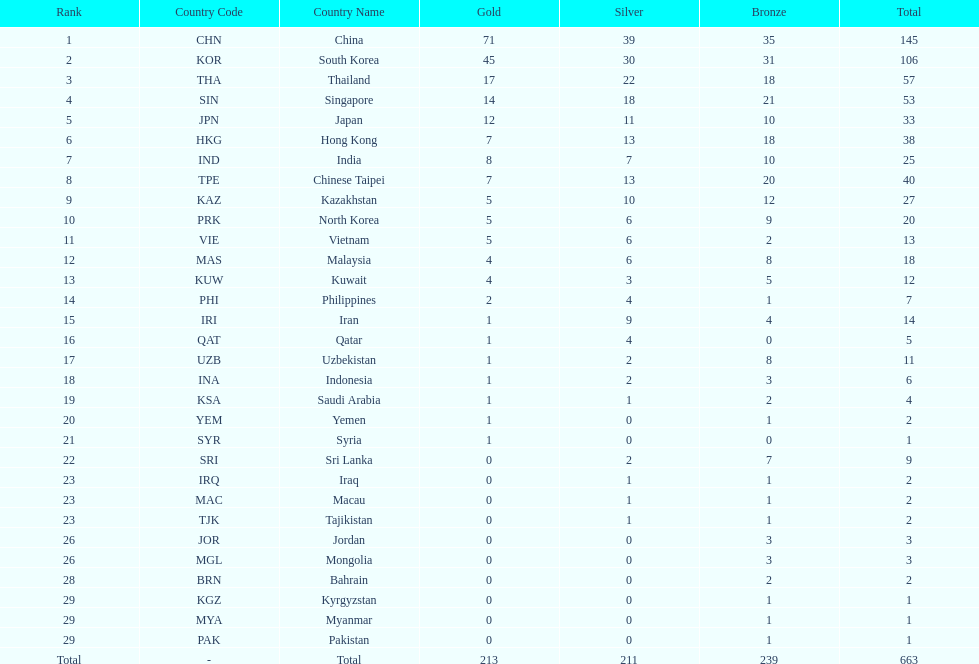Which nation has more gold medals, kuwait or india? India (IND). 